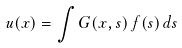Convert formula to latex. <formula><loc_0><loc_0><loc_500><loc_500>u ( x ) = \int G ( x , s ) \, f ( s ) \, d s</formula> 